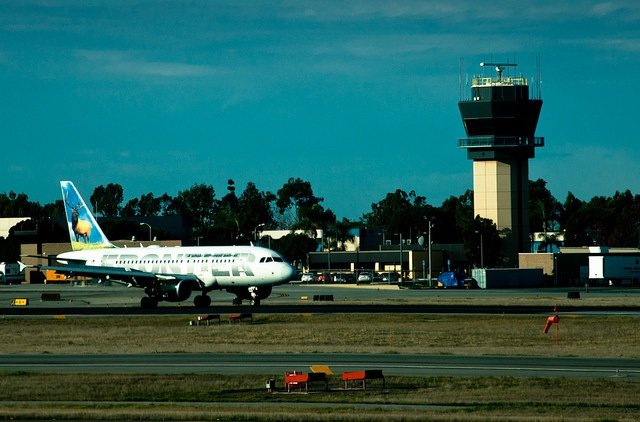Describe the objects in this image and their specific colors. I can see airplane in teal, ivory, black, and lightgreen tones, car in teal, black, and ivory tones, car in teal, black, and ivory tones, car in teal, black, maroon, red, and brown tones, and fire hydrant in maroon, black, brown, and teal tones in this image. 